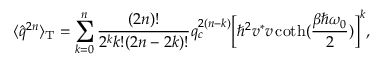<formula> <loc_0><loc_0><loc_500><loc_500>\langle \hat { q } ^ { 2 n } \rangle _ { T } = \sum _ { k = 0 } ^ { n } \frac { ( 2 n ) ! } { 2 ^ { k } k ! ( 2 n - 2 k ) ! } q _ { c } ^ { 2 ( n - k ) } \left [ \hbar { ^ } { 2 } v ^ { * } v \coth ( \frac { \beta \hbar { \omega } _ { 0 } } { 2 } ) \right ] ^ { k } ,</formula> 